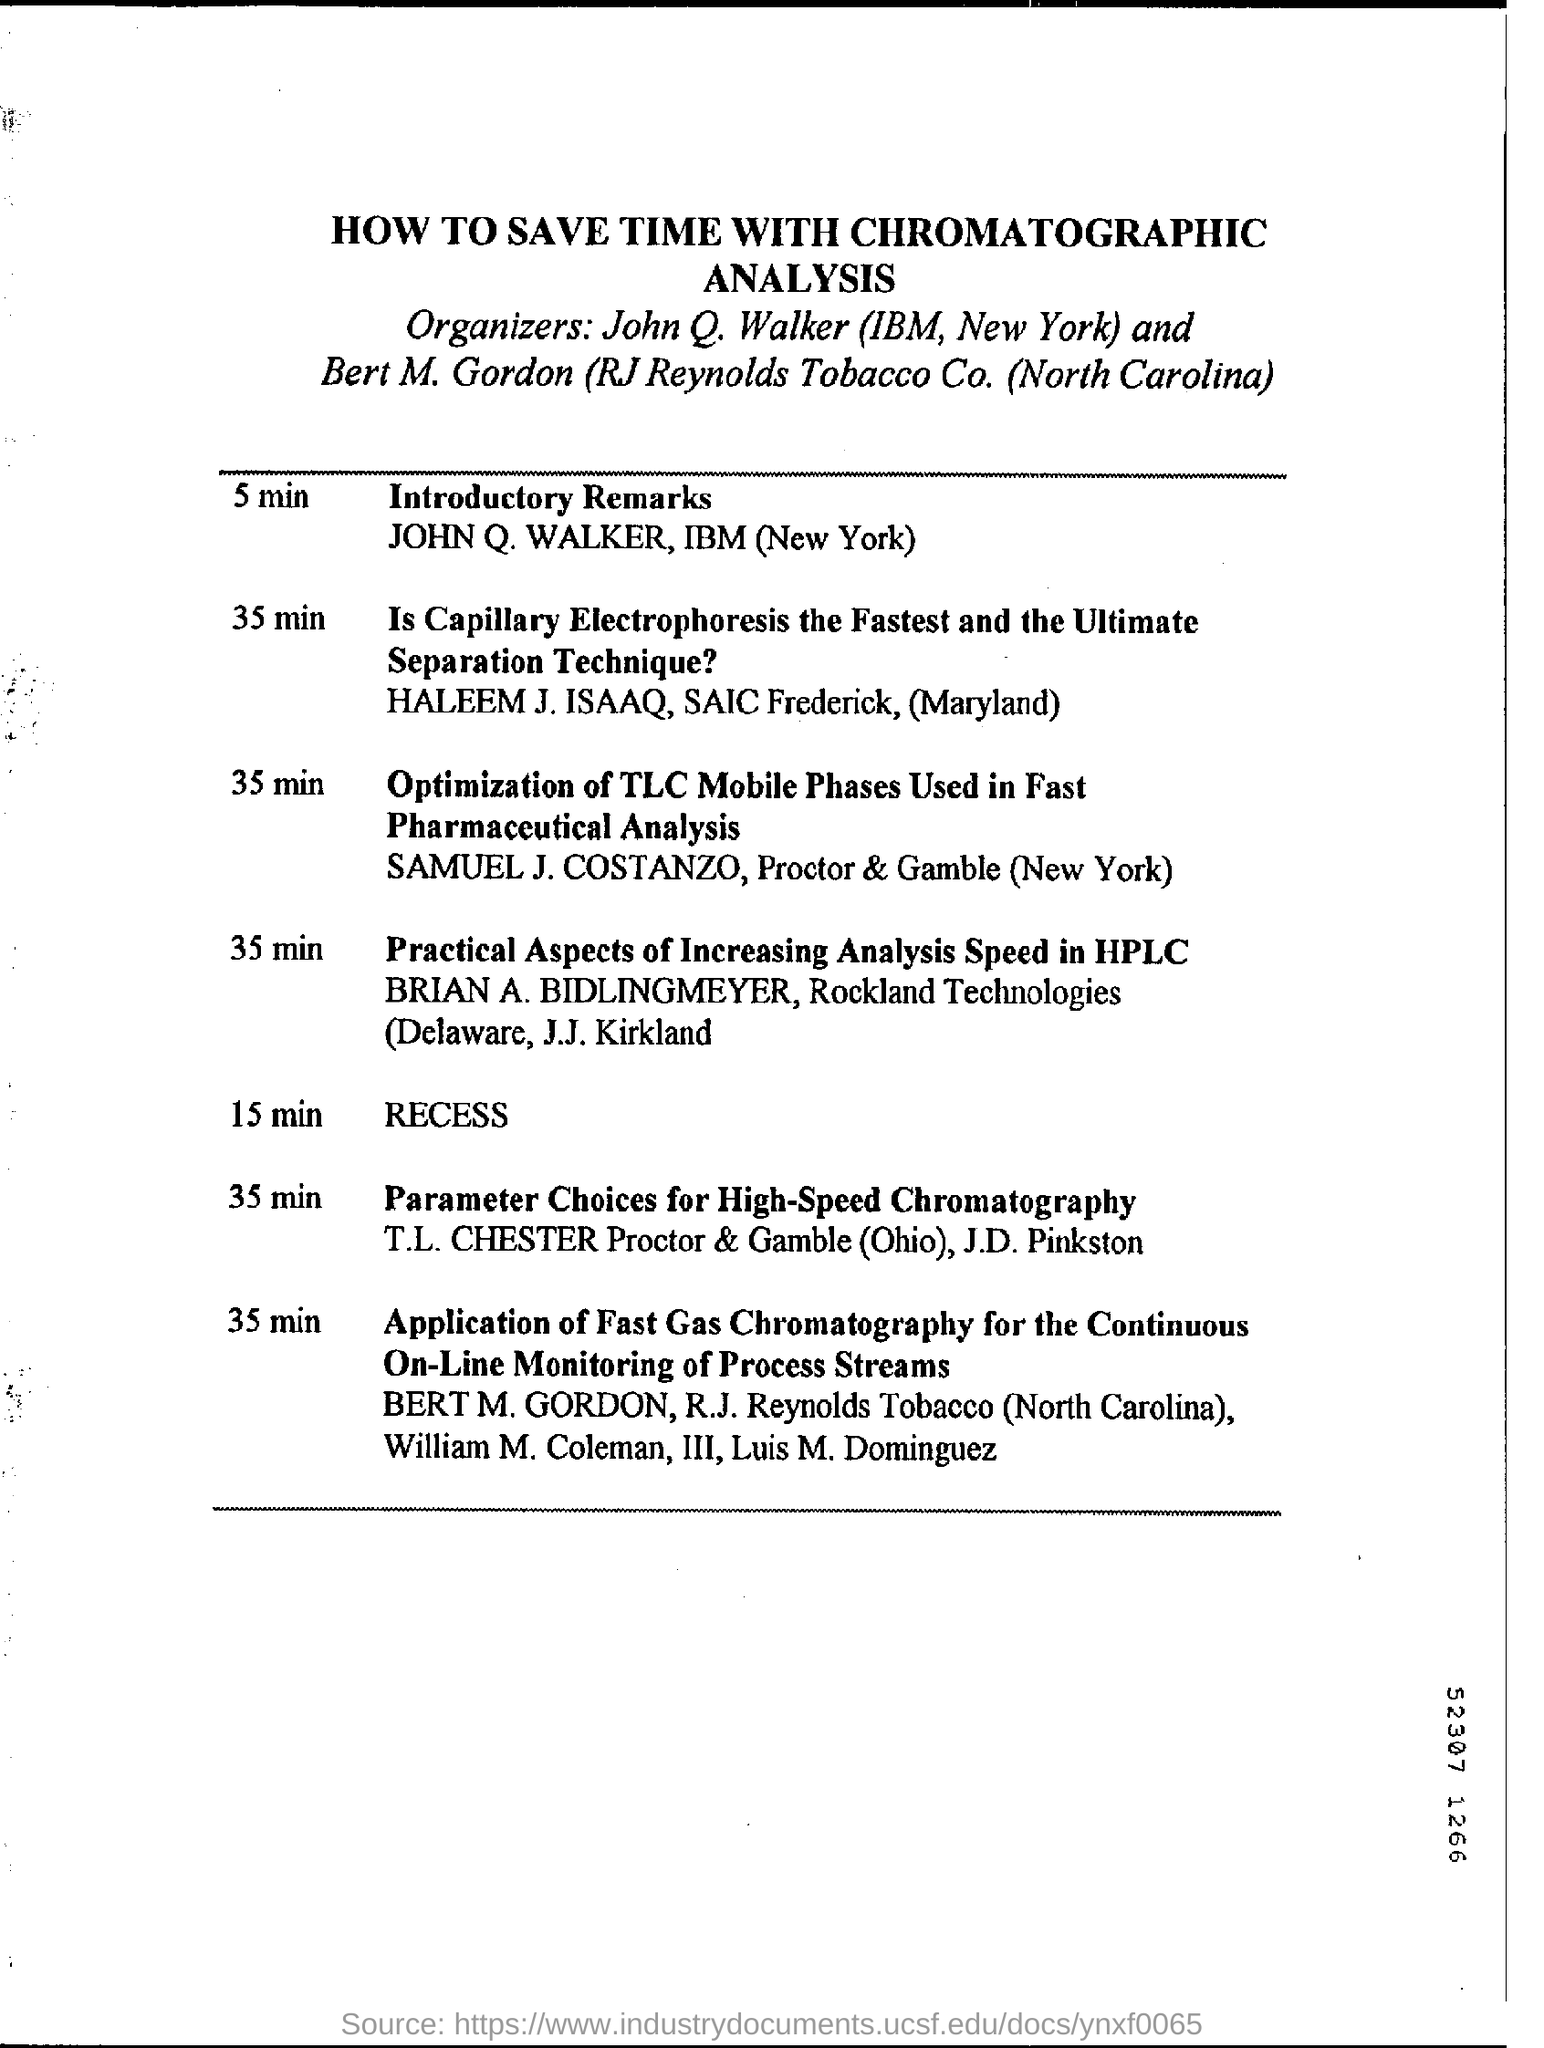Where is John Q. Walker is working?
Keep it short and to the point. IBM. 